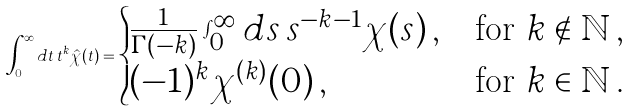Convert formula to latex. <formula><loc_0><loc_0><loc_500><loc_500>\int _ { 0 } ^ { \infty } d t \, t ^ { k } \hat { \chi } ( t ) = \begin{cases} \frac { 1 } { \Gamma ( - k ) } \int _ { 0 } ^ { \infty } d s \, s ^ { - k - 1 } \chi ( s ) \, , & \text {for } k \notin \mathbb { N } \, , \\ ( - 1 ) ^ { k } \chi ^ { ( k ) } ( 0 ) \, , & \text {for } k \in \mathbb { N } \, . \end{cases}</formula> 